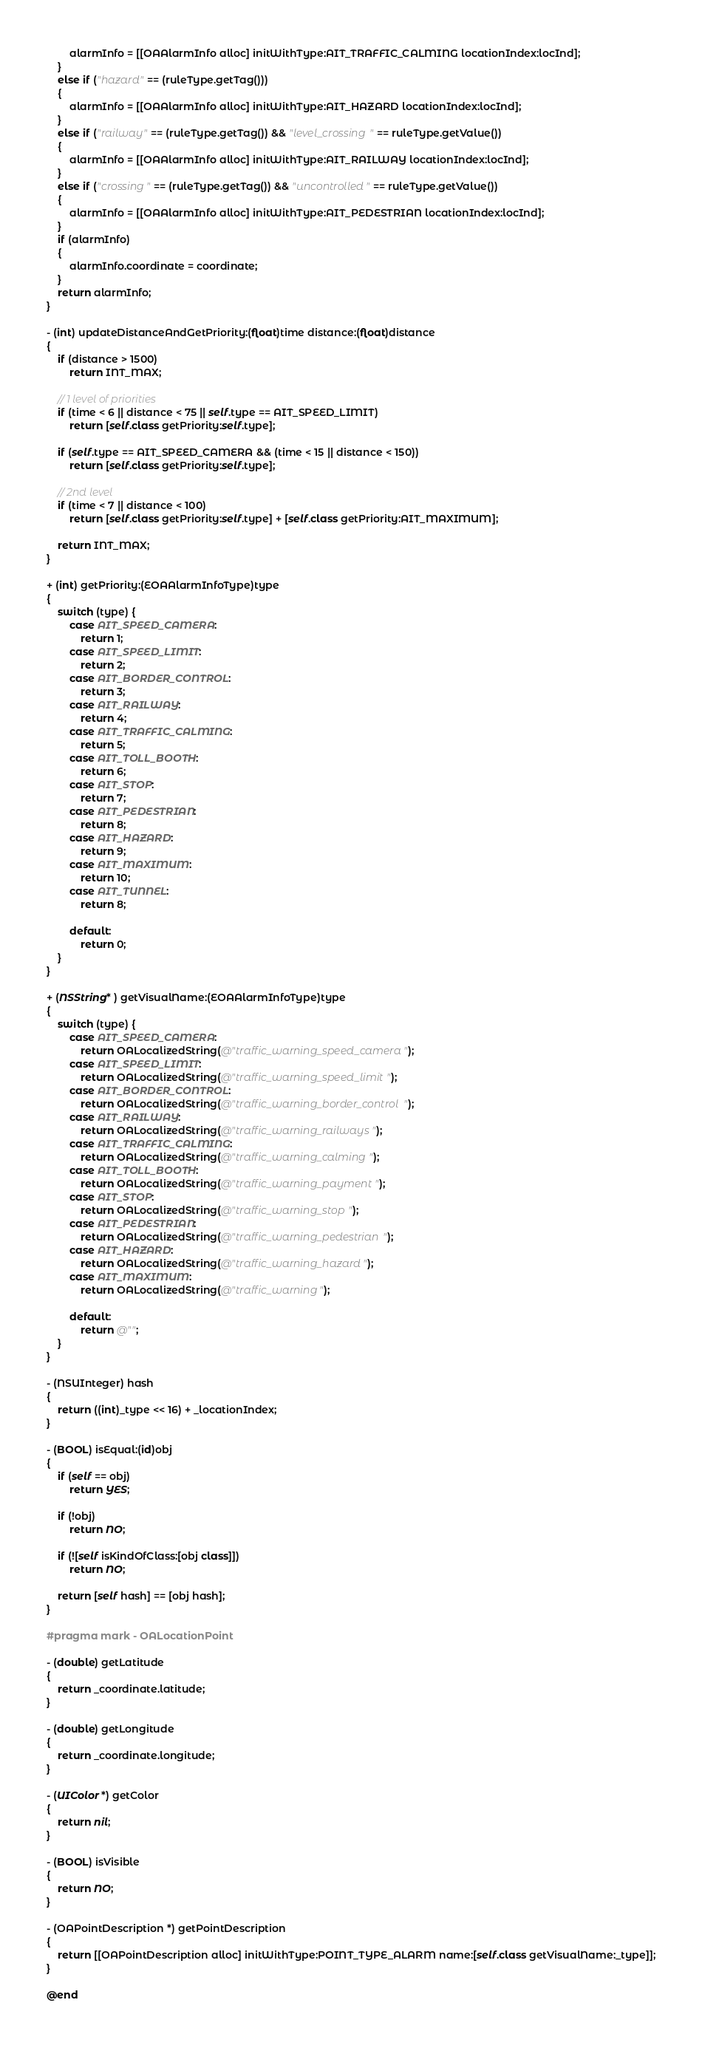Convert code to text. <code><loc_0><loc_0><loc_500><loc_500><_ObjectiveC_>        alarmInfo = [[OAAlarmInfo alloc] initWithType:AIT_TRAFFIC_CALMING locationIndex:locInd];
    }
    else if ("hazard" == (ruleType.getTag()))
    {
        alarmInfo = [[OAAlarmInfo alloc] initWithType:AIT_HAZARD locationIndex:locInd];
    }
    else if ("railway" == (ruleType.getTag()) && "level_crossing" == ruleType.getValue())
    {
        alarmInfo = [[OAAlarmInfo alloc] initWithType:AIT_RAILWAY locationIndex:locInd];
    }
    else if ("crossing" == (ruleType.getTag()) && "uncontrolled" == ruleType.getValue())
    {
        alarmInfo = [[OAAlarmInfo alloc] initWithType:AIT_PEDESTRIAN locationIndex:locInd];
    }
    if (alarmInfo)
    {
        alarmInfo.coordinate = coordinate;
    }
    return alarmInfo;
}

- (int) updateDistanceAndGetPriority:(float)time distance:(float)distance
{
    if (distance > 1500)
        return INT_MAX;
    
    // 1 level of priorities
    if (time < 6 || distance < 75 || self.type == AIT_SPEED_LIMIT)
        return [self.class getPriority:self.type];

    if (self.type == AIT_SPEED_CAMERA && (time < 15 || distance < 150))
        return [self.class getPriority:self.type];

    // 2nd level
    if (time < 7 || distance < 100)
        return [self.class getPriority:self.type] + [self.class getPriority:AIT_MAXIMUM];
    
    return INT_MAX;
}

+ (int) getPriority:(EOAAlarmInfoType)type
{
    switch (type) {
        case AIT_SPEED_CAMERA:
            return 1;
        case AIT_SPEED_LIMIT:
            return 2;
        case AIT_BORDER_CONTROL:
            return 3;
        case AIT_RAILWAY:
            return 4;
        case AIT_TRAFFIC_CALMING:
            return 5;
        case AIT_TOLL_BOOTH:
            return 6;
        case AIT_STOP:
            return 7;
        case AIT_PEDESTRIAN:
            return 8;
        case AIT_HAZARD:
            return 9;
        case AIT_MAXIMUM:
            return 10;
        case AIT_TUNNEL:
            return 8;

        default:
            return 0;
    }
}

+ (NSString* ) getVisualName:(EOAAlarmInfoType)type
{
    switch (type) {
        case AIT_SPEED_CAMERA:
            return OALocalizedString(@"traffic_warning_speed_camera");
        case AIT_SPEED_LIMIT:
            return OALocalizedString(@"traffic_warning_speed_limit");
        case AIT_BORDER_CONTROL:
            return OALocalizedString(@"traffic_warning_border_control");
        case AIT_RAILWAY:
            return OALocalizedString(@"traffic_warning_railways");
        case AIT_TRAFFIC_CALMING:
            return OALocalizedString(@"traffic_warning_calming");
        case AIT_TOLL_BOOTH:
            return OALocalizedString(@"traffic_warning_payment");
        case AIT_STOP:
            return OALocalizedString(@"traffic_warning_stop");
        case AIT_PEDESTRIAN:
            return OALocalizedString(@"traffic_warning_pedestrian");
        case AIT_HAZARD:
            return OALocalizedString(@"traffic_warning_hazard");
        case AIT_MAXIMUM:
            return OALocalizedString(@"traffic_warning");
            
        default:
            return @"";
    }
}

- (NSUInteger) hash
{
    return ((int)_type << 16) + _locationIndex;
}

- (BOOL) isEqual:(id)obj
{
    if (self == obj)
        return YES;
    
    if (!obj)
        return NO;
    
    if (![self isKindOfClass:[obj class]])
        return NO;
    
    return [self hash] == [obj hash];
}

#pragma mark - OALocationPoint

- (double) getLatitude
{
    return _coordinate.latitude;
}

- (double) getLongitude
{
    return _coordinate.longitude;
}

- (UIColor *) getColor
{
    return nil;
}

- (BOOL) isVisible
{
    return NO;
}

- (OAPointDescription *) getPointDescription
{
    return [[OAPointDescription alloc] initWithType:POINT_TYPE_ALARM name:[self.class getVisualName:_type]];
}

@end
</code> 